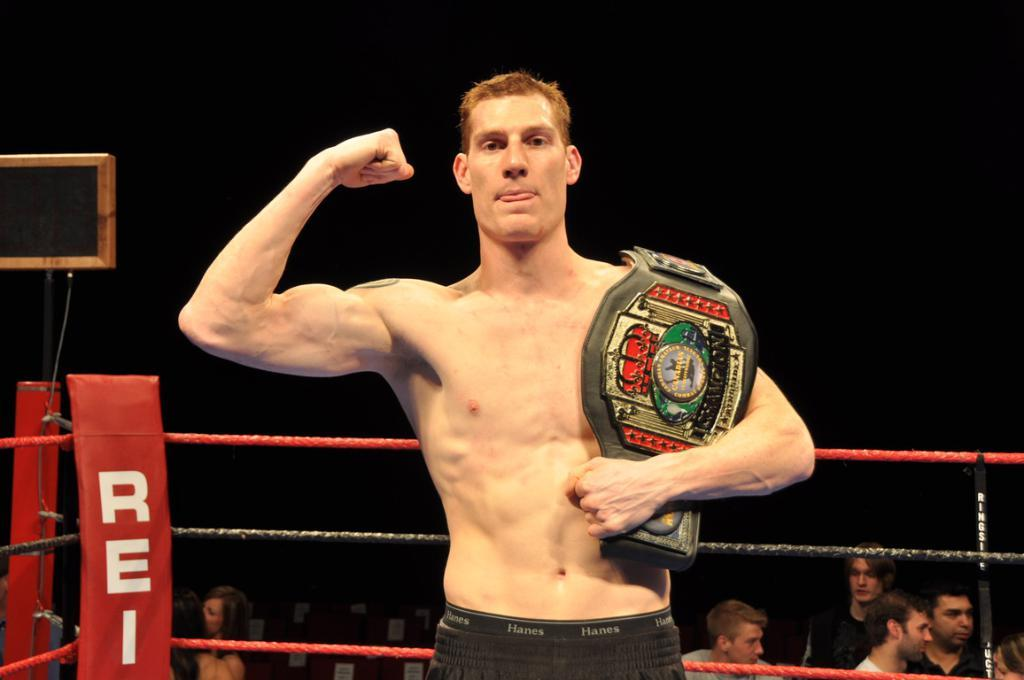<image>
Create a compact narrative representing the image presented. A man proudly holds a wrestling belt inside of a red ring that says REI on it 